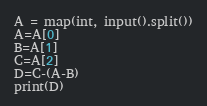Convert code to text. <code><loc_0><loc_0><loc_500><loc_500><_Python_>A = map(int, input().split())
A=A[0]
B=A[1]
C=A[2]
D=C-(A-B)
print(D)</code> 